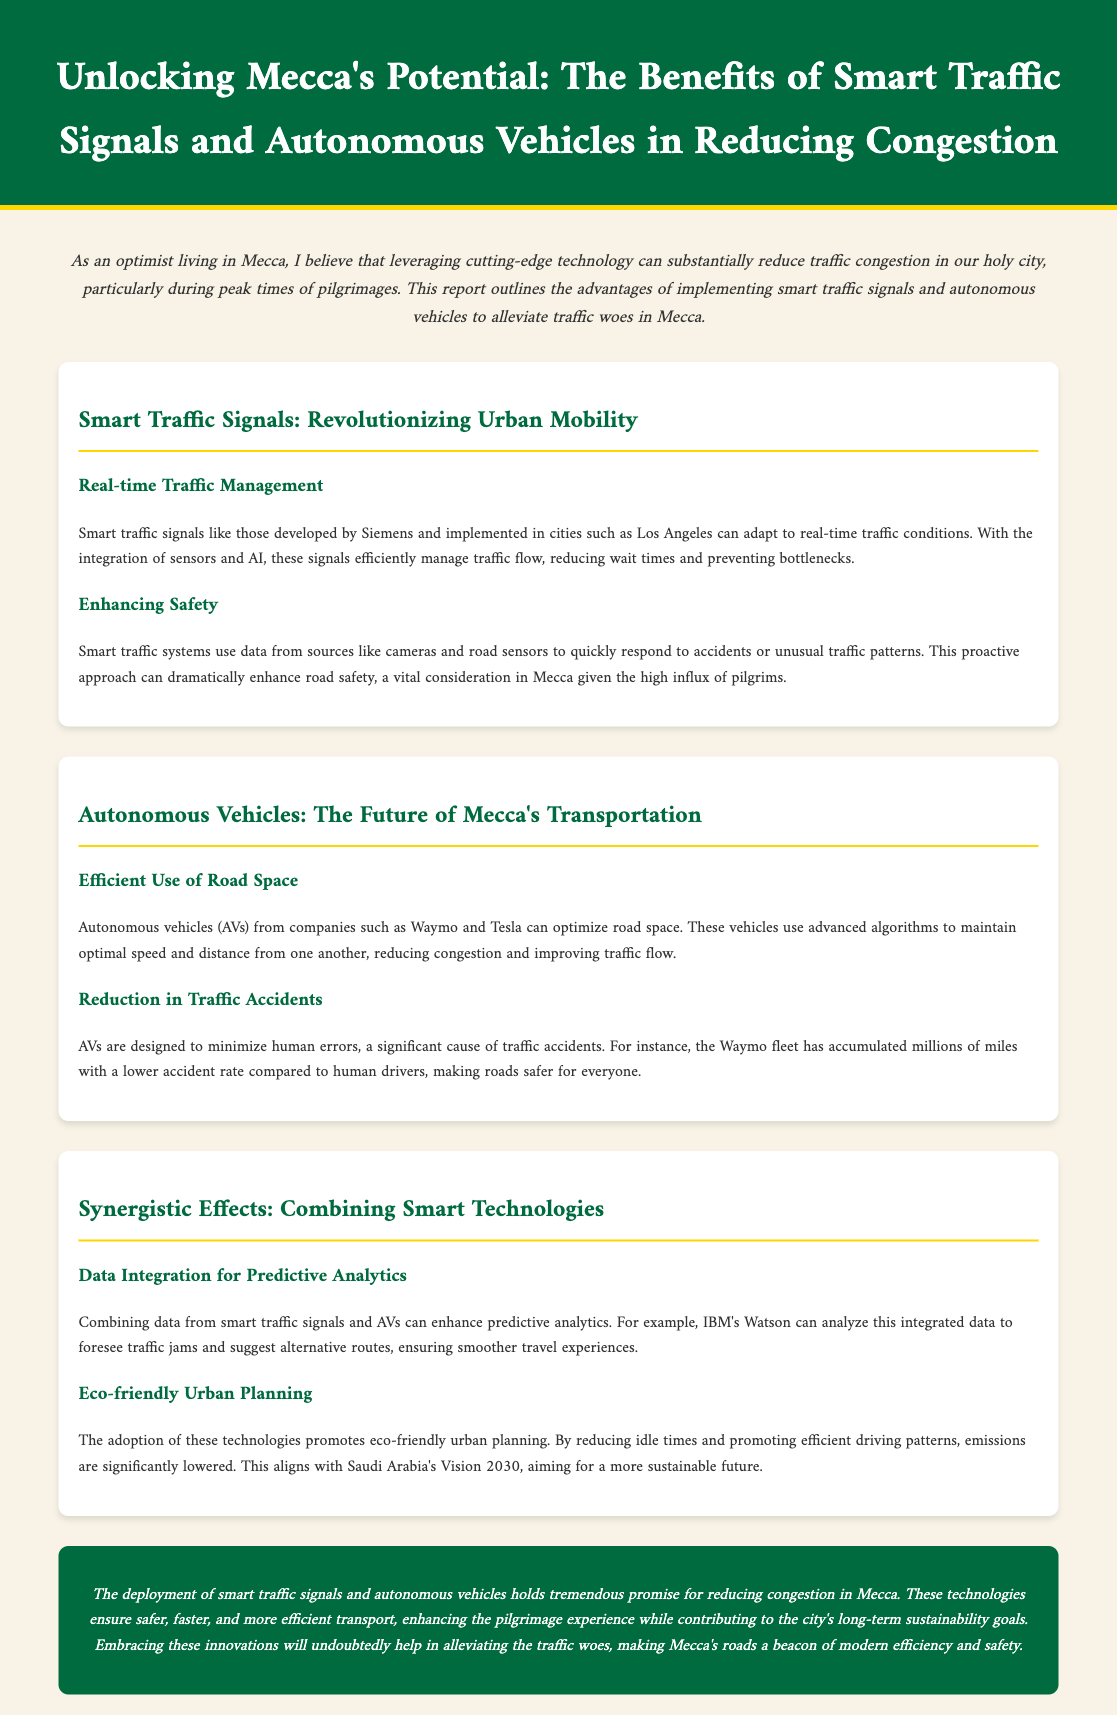what is the title of the report? The title is prominently displayed in the header section of the document.
Answer: Unlocking Mecca's Potential: The Benefits of Smart Traffic Signals and Autonomous Vehicles in Reducing Congestion who developed the smart traffic signals mentioned in the report? The report credits Siemens with the development of smart traffic signals.
Answer: Siemens what is a major benefit of smart traffic signals according to the document? The document states that smart traffic signals manage traffic flow, reducing wait times and preventing bottlenecks.
Answer: reducing wait times which companies are associated with autonomous vehicles in the report? Companies like Waymo and Tesla are mentioned as producers of autonomous vehicles.
Answer: Waymo and Tesla what is the total focus of the report? The report focuses on the benefits of technology in reducing traffic congestion in Mecca.
Answer: reducing traffic congestion how can data from smart signals and AVs improve traffic management? The integration of these technologies enhances predictive analytics for traffic management.
Answer: predictive analytics what key aspect does the conclusion highlight about smart technologies? The conclusion emphasizes the promise of these technologies for enhancing transport efficiency and safety.
Answer: enhancing transport efficiency what is a vision that aligns with the technology adoption discussed in the report? The document aligns the technology adoption with Saudi Arabia's Vision 2030.
Answer: Vision 2030 